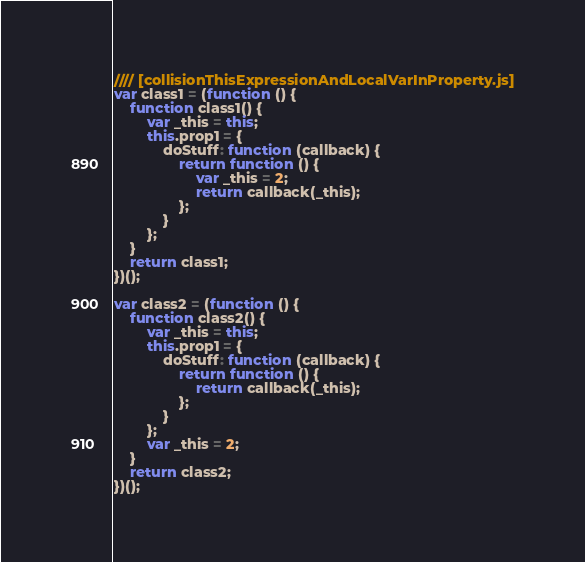Convert code to text. <code><loc_0><loc_0><loc_500><loc_500><_JavaScript_>//// [collisionThisExpressionAndLocalVarInProperty.js]
var class1 = (function () {
    function class1() {
        var _this = this;
        this.prop1 = {
            doStuff: function (callback) {
                return function () {
                    var _this = 2;
                    return callback(_this);
                };
            }
        };
    }
    return class1;
})();

var class2 = (function () {
    function class2() {
        var _this = this;
        this.prop1 = {
            doStuff: function (callback) {
                return function () {
                    return callback(_this);
                };
            }
        };
        var _this = 2;
    }
    return class2;
})();
</code> 